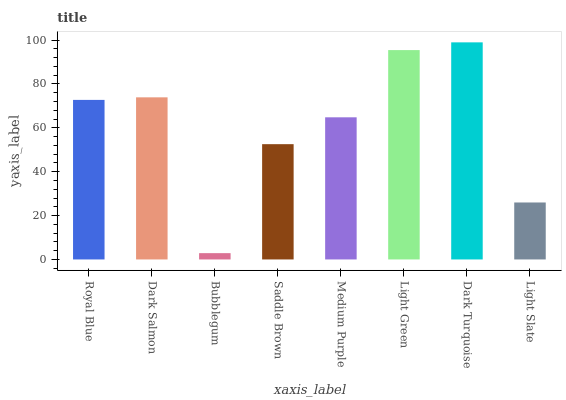Is Bubblegum the minimum?
Answer yes or no. Yes. Is Dark Turquoise the maximum?
Answer yes or no. Yes. Is Dark Salmon the minimum?
Answer yes or no. No. Is Dark Salmon the maximum?
Answer yes or no. No. Is Dark Salmon greater than Royal Blue?
Answer yes or no. Yes. Is Royal Blue less than Dark Salmon?
Answer yes or no. Yes. Is Royal Blue greater than Dark Salmon?
Answer yes or no. No. Is Dark Salmon less than Royal Blue?
Answer yes or no. No. Is Royal Blue the high median?
Answer yes or no. Yes. Is Medium Purple the low median?
Answer yes or no. Yes. Is Bubblegum the high median?
Answer yes or no. No. Is Bubblegum the low median?
Answer yes or no. No. 